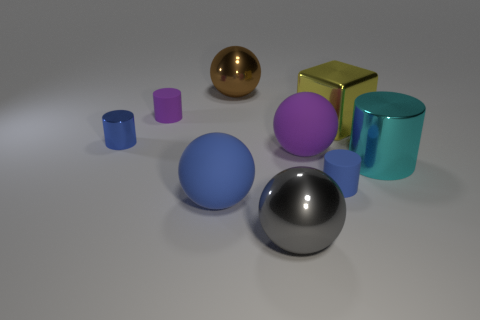Subtract all tiny cylinders. How many cylinders are left? 1 Subtract all purple cylinders. How many cylinders are left? 3 Add 1 purple rubber cylinders. How many objects exist? 10 Subtract all cylinders. How many objects are left? 5 Subtract 4 balls. How many balls are left? 0 Add 2 blue matte cylinders. How many blue matte cylinders are left? 3 Add 4 small yellow rubber blocks. How many small yellow rubber blocks exist? 4 Subtract 1 blue cylinders. How many objects are left? 8 Subtract all purple cylinders. Subtract all purple spheres. How many cylinders are left? 3 Subtract all brown spheres. How many cyan cylinders are left? 1 